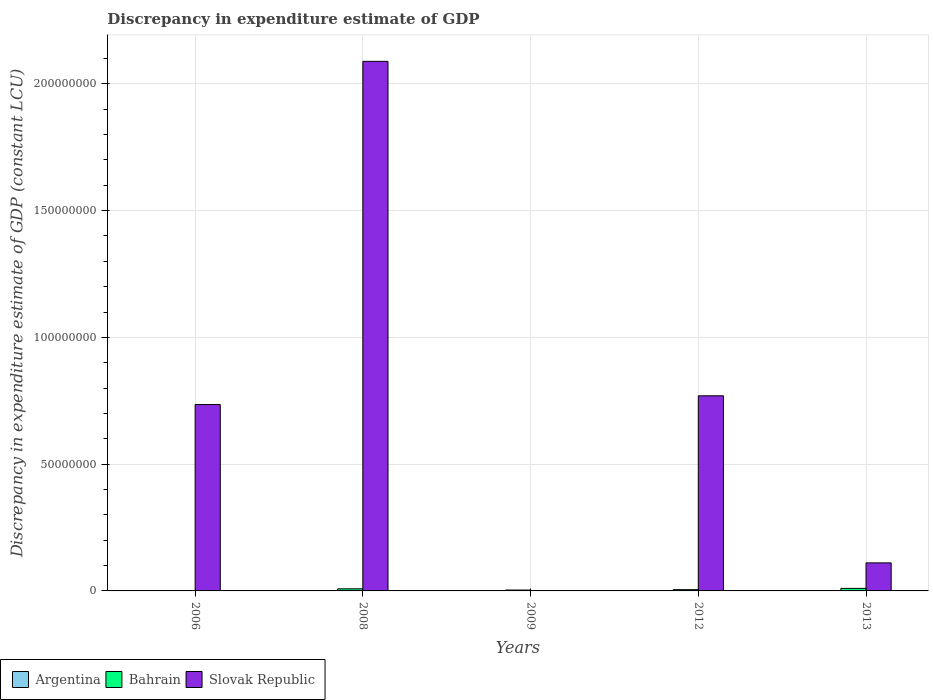How many different coloured bars are there?
Your response must be concise. 3. How many groups of bars are there?
Offer a terse response. 5. Are the number of bars on each tick of the X-axis equal?
Give a very brief answer. No. What is the discrepancy in expenditure estimate of GDP in Bahrain in 2008?
Provide a succinct answer. 8.30e+05. Across all years, what is the minimum discrepancy in expenditure estimate of GDP in Bahrain?
Ensure brevity in your answer.  10000. What is the total discrepancy in expenditure estimate of GDP in Argentina in the graph?
Ensure brevity in your answer.  3.50e+04. What is the difference between the discrepancy in expenditure estimate of GDP in Bahrain in 2008 and the discrepancy in expenditure estimate of GDP in Argentina in 2013?
Offer a very short reply. 8.30e+05. What is the average discrepancy in expenditure estimate of GDP in Bahrain per year?
Your response must be concise. 5.38e+05. In the year 2012, what is the difference between the discrepancy in expenditure estimate of GDP in Argentina and discrepancy in expenditure estimate of GDP in Bahrain?
Your answer should be very brief. -4.66e+05. What is the ratio of the discrepancy in expenditure estimate of GDP in Bahrain in 2008 to that in 2009?
Provide a succinct answer. 2.37. What is the difference between the highest and the second highest discrepancy in expenditure estimate of GDP in Slovak Republic?
Make the answer very short. 1.32e+08. What is the difference between the highest and the lowest discrepancy in expenditure estimate of GDP in Argentina?
Give a very brief answer. 3.40e+04. In how many years, is the discrepancy in expenditure estimate of GDP in Argentina greater than the average discrepancy in expenditure estimate of GDP in Argentina taken over all years?
Your answer should be compact. 1. Is the sum of the discrepancy in expenditure estimate of GDP in Slovak Republic in 2006 and 2012 greater than the maximum discrepancy in expenditure estimate of GDP in Argentina across all years?
Provide a succinct answer. Yes. How many bars are there?
Your answer should be very brief. 11. Does the graph contain any zero values?
Provide a succinct answer. Yes. Does the graph contain grids?
Give a very brief answer. Yes. Where does the legend appear in the graph?
Offer a very short reply. Bottom left. How are the legend labels stacked?
Offer a very short reply. Horizontal. What is the title of the graph?
Provide a short and direct response. Discrepancy in expenditure estimate of GDP. Does "Myanmar" appear as one of the legend labels in the graph?
Your answer should be compact. No. What is the label or title of the Y-axis?
Your response must be concise. Discrepancy in expenditure estimate of GDP (constant LCU). What is the Discrepancy in expenditure estimate of GDP (constant LCU) in Bahrain in 2006?
Your answer should be compact. 10000. What is the Discrepancy in expenditure estimate of GDP (constant LCU) of Slovak Republic in 2006?
Provide a short and direct response. 7.35e+07. What is the Discrepancy in expenditure estimate of GDP (constant LCU) in Bahrain in 2008?
Provide a succinct answer. 8.30e+05. What is the Discrepancy in expenditure estimate of GDP (constant LCU) of Slovak Republic in 2008?
Your response must be concise. 2.09e+08. What is the Discrepancy in expenditure estimate of GDP (constant LCU) of Bahrain in 2009?
Ensure brevity in your answer.  3.50e+05. What is the Discrepancy in expenditure estimate of GDP (constant LCU) of Slovak Republic in 2009?
Make the answer very short. 0. What is the Discrepancy in expenditure estimate of GDP (constant LCU) of Argentina in 2012?
Ensure brevity in your answer.  3.40e+04. What is the Discrepancy in expenditure estimate of GDP (constant LCU) in Bahrain in 2012?
Provide a short and direct response. 5.00e+05. What is the Discrepancy in expenditure estimate of GDP (constant LCU) in Slovak Republic in 2012?
Offer a very short reply. 7.70e+07. What is the Discrepancy in expenditure estimate of GDP (constant LCU) of Argentina in 2013?
Your response must be concise. 0. What is the Discrepancy in expenditure estimate of GDP (constant LCU) of Slovak Republic in 2013?
Offer a terse response. 1.11e+07. Across all years, what is the maximum Discrepancy in expenditure estimate of GDP (constant LCU) in Argentina?
Offer a very short reply. 3.40e+04. Across all years, what is the maximum Discrepancy in expenditure estimate of GDP (constant LCU) in Slovak Republic?
Give a very brief answer. 2.09e+08. Across all years, what is the minimum Discrepancy in expenditure estimate of GDP (constant LCU) in Bahrain?
Keep it short and to the point. 10000. Across all years, what is the minimum Discrepancy in expenditure estimate of GDP (constant LCU) of Slovak Republic?
Your answer should be very brief. 0. What is the total Discrepancy in expenditure estimate of GDP (constant LCU) in Argentina in the graph?
Ensure brevity in your answer.  3.50e+04. What is the total Discrepancy in expenditure estimate of GDP (constant LCU) of Bahrain in the graph?
Ensure brevity in your answer.  2.69e+06. What is the total Discrepancy in expenditure estimate of GDP (constant LCU) of Slovak Republic in the graph?
Make the answer very short. 3.70e+08. What is the difference between the Discrepancy in expenditure estimate of GDP (constant LCU) in Bahrain in 2006 and that in 2008?
Ensure brevity in your answer.  -8.20e+05. What is the difference between the Discrepancy in expenditure estimate of GDP (constant LCU) of Slovak Republic in 2006 and that in 2008?
Make the answer very short. -1.35e+08. What is the difference between the Discrepancy in expenditure estimate of GDP (constant LCU) in Bahrain in 2006 and that in 2009?
Provide a succinct answer. -3.40e+05. What is the difference between the Discrepancy in expenditure estimate of GDP (constant LCU) of Bahrain in 2006 and that in 2012?
Provide a succinct answer. -4.90e+05. What is the difference between the Discrepancy in expenditure estimate of GDP (constant LCU) of Slovak Republic in 2006 and that in 2012?
Offer a very short reply. -3.44e+06. What is the difference between the Discrepancy in expenditure estimate of GDP (constant LCU) in Bahrain in 2006 and that in 2013?
Offer a terse response. -9.90e+05. What is the difference between the Discrepancy in expenditure estimate of GDP (constant LCU) in Slovak Republic in 2006 and that in 2013?
Ensure brevity in your answer.  6.24e+07. What is the difference between the Discrepancy in expenditure estimate of GDP (constant LCU) of Bahrain in 2008 and that in 2012?
Offer a terse response. 3.30e+05. What is the difference between the Discrepancy in expenditure estimate of GDP (constant LCU) of Slovak Republic in 2008 and that in 2012?
Make the answer very short. 1.32e+08. What is the difference between the Discrepancy in expenditure estimate of GDP (constant LCU) in Slovak Republic in 2008 and that in 2013?
Your response must be concise. 1.98e+08. What is the difference between the Discrepancy in expenditure estimate of GDP (constant LCU) of Argentina in 2009 and that in 2012?
Your response must be concise. -3.30e+04. What is the difference between the Discrepancy in expenditure estimate of GDP (constant LCU) in Bahrain in 2009 and that in 2013?
Ensure brevity in your answer.  -6.50e+05. What is the difference between the Discrepancy in expenditure estimate of GDP (constant LCU) in Bahrain in 2012 and that in 2013?
Provide a short and direct response. -5.00e+05. What is the difference between the Discrepancy in expenditure estimate of GDP (constant LCU) in Slovak Republic in 2012 and that in 2013?
Give a very brief answer. 6.59e+07. What is the difference between the Discrepancy in expenditure estimate of GDP (constant LCU) in Bahrain in 2006 and the Discrepancy in expenditure estimate of GDP (constant LCU) in Slovak Republic in 2008?
Ensure brevity in your answer.  -2.09e+08. What is the difference between the Discrepancy in expenditure estimate of GDP (constant LCU) in Bahrain in 2006 and the Discrepancy in expenditure estimate of GDP (constant LCU) in Slovak Republic in 2012?
Offer a very short reply. -7.69e+07. What is the difference between the Discrepancy in expenditure estimate of GDP (constant LCU) of Bahrain in 2006 and the Discrepancy in expenditure estimate of GDP (constant LCU) of Slovak Republic in 2013?
Offer a very short reply. -1.10e+07. What is the difference between the Discrepancy in expenditure estimate of GDP (constant LCU) of Bahrain in 2008 and the Discrepancy in expenditure estimate of GDP (constant LCU) of Slovak Republic in 2012?
Offer a terse response. -7.61e+07. What is the difference between the Discrepancy in expenditure estimate of GDP (constant LCU) in Bahrain in 2008 and the Discrepancy in expenditure estimate of GDP (constant LCU) in Slovak Republic in 2013?
Offer a very short reply. -1.02e+07. What is the difference between the Discrepancy in expenditure estimate of GDP (constant LCU) in Argentina in 2009 and the Discrepancy in expenditure estimate of GDP (constant LCU) in Bahrain in 2012?
Make the answer very short. -4.99e+05. What is the difference between the Discrepancy in expenditure estimate of GDP (constant LCU) in Argentina in 2009 and the Discrepancy in expenditure estimate of GDP (constant LCU) in Slovak Republic in 2012?
Make the answer very short. -7.70e+07. What is the difference between the Discrepancy in expenditure estimate of GDP (constant LCU) of Bahrain in 2009 and the Discrepancy in expenditure estimate of GDP (constant LCU) of Slovak Republic in 2012?
Offer a terse response. -7.66e+07. What is the difference between the Discrepancy in expenditure estimate of GDP (constant LCU) in Argentina in 2009 and the Discrepancy in expenditure estimate of GDP (constant LCU) in Bahrain in 2013?
Provide a succinct answer. -9.99e+05. What is the difference between the Discrepancy in expenditure estimate of GDP (constant LCU) of Argentina in 2009 and the Discrepancy in expenditure estimate of GDP (constant LCU) of Slovak Republic in 2013?
Your answer should be compact. -1.11e+07. What is the difference between the Discrepancy in expenditure estimate of GDP (constant LCU) of Bahrain in 2009 and the Discrepancy in expenditure estimate of GDP (constant LCU) of Slovak Republic in 2013?
Offer a very short reply. -1.07e+07. What is the difference between the Discrepancy in expenditure estimate of GDP (constant LCU) of Argentina in 2012 and the Discrepancy in expenditure estimate of GDP (constant LCU) of Bahrain in 2013?
Your answer should be very brief. -9.66e+05. What is the difference between the Discrepancy in expenditure estimate of GDP (constant LCU) of Argentina in 2012 and the Discrepancy in expenditure estimate of GDP (constant LCU) of Slovak Republic in 2013?
Keep it short and to the point. -1.10e+07. What is the difference between the Discrepancy in expenditure estimate of GDP (constant LCU) of Bahrain in 2012 and the Discrepancy in expenditure estimate of GDP (constant LCU) of Slovak Republic in 2013?
Give a very brief answer. -1.06e+07. What is the average Discrepancy in expenditure estimate of GDP (constant LCU) in Argentina per year?
Your answer should be compact. 7000. What is the average Discrepancy in expenditure estimate of GDP (constant LCU) in Bahrain per year?
Keep it short and to the point. 5.38e+05. What is the average Discrepancy in expenditure estimate of GDP (constant LCU) of Slovak Republic per year?
Your answer should be very brief. 7.41e+07. In the year 2006, what is the difference between the Discrepancy in expenditure estimate of GDP (constant LCU) in Bahrain and Discrepancy in expenditure estimate of GDP (constant LCU) in Slovak Republic?
Give a very brief answer. -7.35e+07. In the year 2008, what is the difference between the Discrepancy in expenditure estimate of GDP (constant LCU) in Bahrain and Discrepancy in expenditure estimate of GDP (constant LCU) in Slovak Republic?
Keep it short and to the point. -2.08e+08. In the year 2009, what is the difference between the Discrepancy in expenditure estimate of GDP (constant LCU) of Argentina and Discrepancy in expenditure estimate of GDP (constant LCU) of Bahrain?
Make the answer very short. -3.49e+05. In the year 2012, what is the difference between the Discrepancy in expenditure estimate of GDP (constant LCU) in Argentina and Discrepancy in expenditure estimate of GDP (constant LCU) in Bahrain?
Offer a terse response. -4.66e+05. In the year 2012, what is the difference between the Discrepancy in expenditure estimate of GDP (constant LCU) in Argentina and Discrepancy in expenditure estimate of GDP (constant LCU) in Slovak Republic?
Ensure brevity in your answer.  -7.69e+07. In the year 2012, what is the difference between the Discrepancy in expenditure estimate of GDP (constant LCU) of Bahrain and Discrepancy in expenditure estimate of GDP (constant LCU) of Slovak Republic?
Offer a terse response. -7.65e+07. In the year 2013, what is the difference between the Discrepancy in expenditure estimate of GDP (constant LCU) in Bahrain and Discrepancy in expenditure estimate of GDP (constant LCU) in Slovak Republic?
Offer a very short reply. -1.01e+07. What is the ratio of the Discrepancy in expenditure estimate of GDP (constant LCU) of Bahrain in 2006 to that in 2008?
Your answer should be compact. 0.01. What is the ratio of the Discrepancy in expenditure estimate of GDP (constant LCU) in Slovak Republic in 2006 to that in 2008?
Your answer should be compact. 0.35. What is the ratio of the Discrepancy in expenditure estimate of GDP (constant LCU) in Bahrain in 2006 to that in 2009?
Provide a succinct answer. 0.03. What is the ratio of the Discrepancy in expenditure estimate of GDP (constant LCU) of Bahrain in 2006 to that in 2012?
Your answer should be very brief. 0.02. What is the ratio of the Discrepancy in expenditure estimate of GDP (constant LCU) of Slovak Republic in 2006 to that in 2012?
Offer a very short reply. 0.96. What is the ratio of the Discrepancy in expenditure estimate of GDP (constant LCU) in Bahrain in 2006 to that in 2013?
Keep it short and to the point. 0.01. What is the ratio of the Discrepancy in expenditure estimate of GDP (constant LCU) of Slovak Republic in 2006 to that in 2013?
Ensure brevity in your answer.  6.65. What is the ratio of the Discrepancy in expenditure estimate of GDP (constant LCU) in Bahrain in 2008 to that in 2009?
Your answer should be compact. 2.37. What is the ratio of the Discrepancy in expenditure estimate of GDP (constant LCU) in Bahrain in 2008 to that in 2012?
Ensure brevity in your answer.  1.66. What is the ratio of the Discrepancy in expenditure estimate of GDP (constant LCU) of Slovak Republic in 2008 to that in 2012?
Keep it short and to the point. 2.71. What is the ratio of the Discrepancy in expenditure estimate of GDP (constant LCU) of Bahrain in 2008 to that in 2013?
Provide a succinct answer. 0.83. What is the ratio of the Discrepancy in expenditure estimate of GDP (constant LCU) of Slovak Republic in 2008 to that in 2013?
Your response must be concise. 18.89. What is the ratio of the Discrepancy in expenditure estimate of GDP (constant LCU) of Argentina in 2009 to that in 2012?
Make the answer very short. 0.03. What is the ratio of the Discrepancy in expenditure estimate of GDP (constant LCU) of Bahrain in 2009 to that in 2012?
Offer a very short reply. 0.7. What is the ratio of the Discrepancy in expenditure estimate of GDP (constant LCU) of Bahrain in 2009 to that in 2013?
Your response must be concise. 0.35. What is the ratio of the Discrepancy in expenditure estimate of GDP (constant LCU) in Slovak Republic in 2012 to that in 2013?
Make the answer very short. 6.96. What is the difference between the highest and the second highest Discrepancy in expenditure estimate of GDP (constant LCU) in Bahrain?
Your answer should be compact. 1.70e+05. What is the difference between the highest and the second highest Discrepancy in expenditure estimate of GDP (constant LCU) in Slovak Republic?
Offer a terse response. 1.32e+08. What is the difference between the highest and the lowest Discrepancy in expenditure estimate of GDP (constant LCU) in Argentina?
Provide a succinct answer. 3.40e+04. What is the difference between the highest and the lowest Discrepancy in expenditure estimate of GDP (constant LCU) of Bahrain?
Your answer should be compact. 9.90e+05. What is the difference between the highest and the lowest Discrepancy in expenditure estimate of GDP (constant LCU) in Slovak Republic?
Provide a short and direct response. 2.09e+08. 